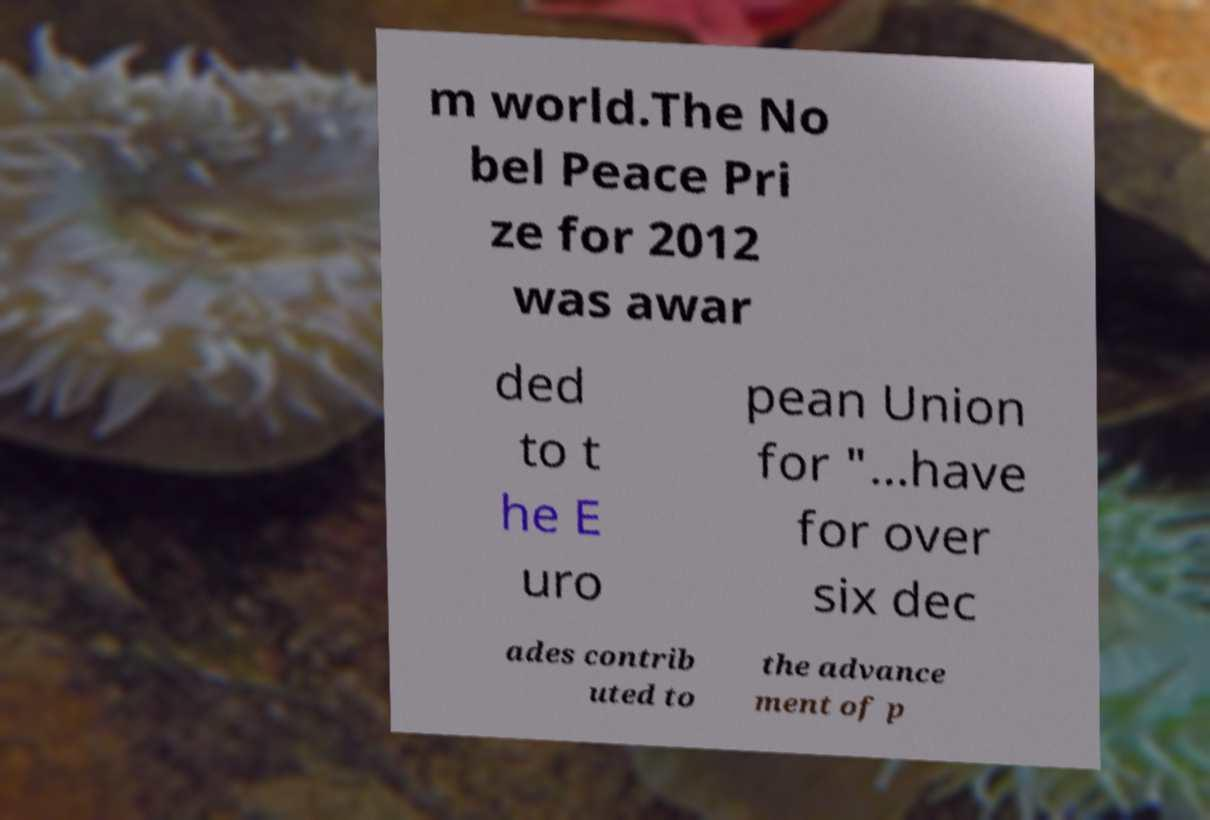Could you extract and type out the text from this image? m world.The No bel Peace Pri ze for 2012 was awar ded to t he E uro pean Union for "...have for over six dec ades contrib uted to the advance ment of p 